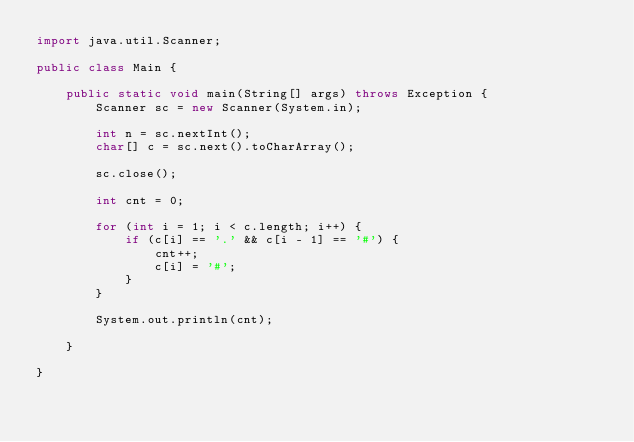Convert code to text. <code><loc_0><loc_0><loc_500><loc_500><_Java_>import java.util.Scanner;

public class Main {

    public static void main(String[] args) throws Exception {
        Scanner sc = new Scanner(System.in);

        int n = sc.nextInt();
        char[] c = sc.next().toCharArray();

        sc.close();

        int cnt = 0;

        for (int i = 1; i < c.length; i++) {
            if (c[i] == '.' && c[i - 1] == '#') {
                cnt++;
                c[i] = '#';
            }
        }

        System.out.println(cnt);

    }

}</code> 